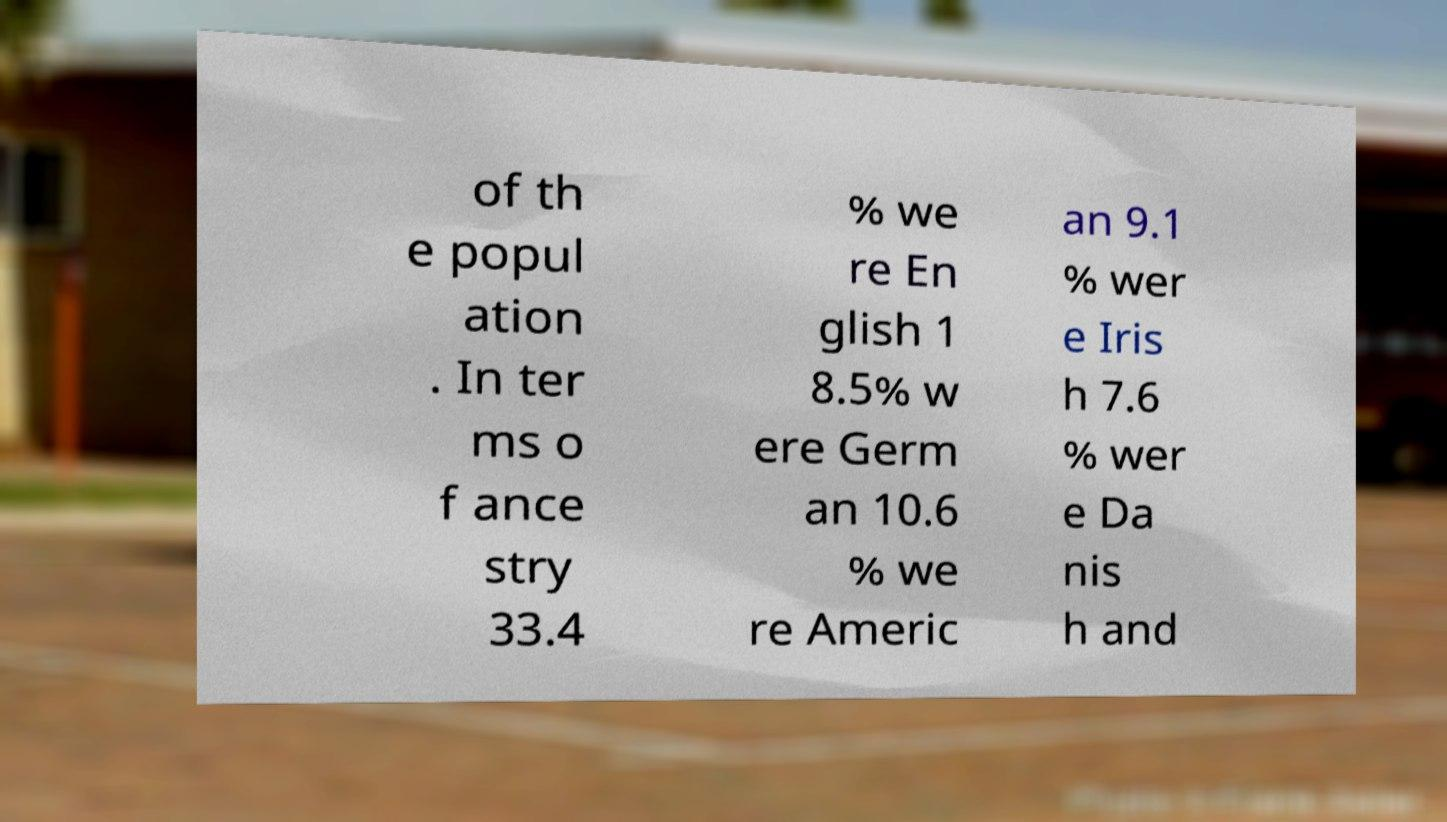I need the written content from this picture converted into text. Can you do that? of th e popul ation . In ter ms o f ance stry 33.4 % we re En glish 1 8.5% w ere Germ an 10.6 % we re Americ an 9.1 % wer e Iris h 7.6 % wer e Da nis h and 